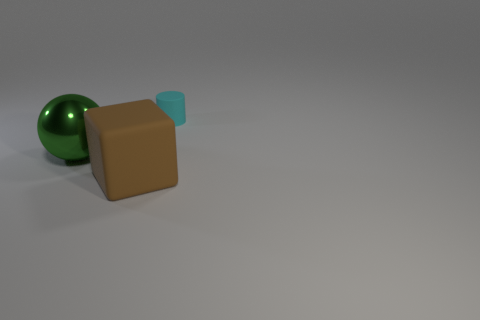What is the color of the block that is the same size as the ball?
Provide a succinct answer. Brown. Are there any large green metal balls that are to the left of the thing that is in front of the object on the left side of the block?
Your response must be concise. Yes. How big is the cyan cylinder?
Keep it short and to the point. Small. What number of objects are tiny cyan shiny things or small cyan cylinders?
Your answer should be compact. 1. The other thing that is made of the same material as the tiny thing is what color?
Your response must be concise. Brown. What number of things are either matte objects that are in front of the cyan thing or rubber things that are in front of the small cyan matte thing?
Offer a terse response. 1. Is there anything else that is the same shape as the large green shiny thing?
Your answer should be very brief. No. What is the material of the cyan cylinder?
Make the answer very short. Rubber. What number of other objects are the same material as the small cyan thing?
Keep it short and to the point. 1. Does the tiny cylinder have the same material as the large thing that is in front of the green metal sphere?
Keep it short and to the point. Yes. 